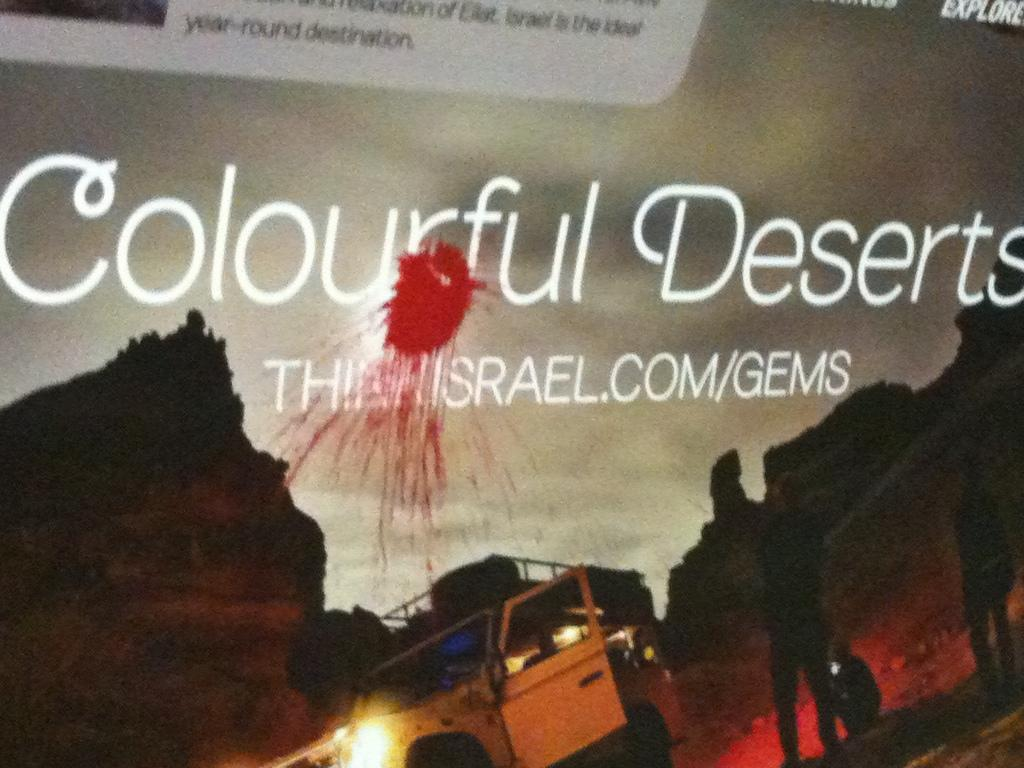<image>
Describe the image concisely. A billboard of saying "Colourful Deserts" has been vandalized with red pain probably thrown in the balloon. 